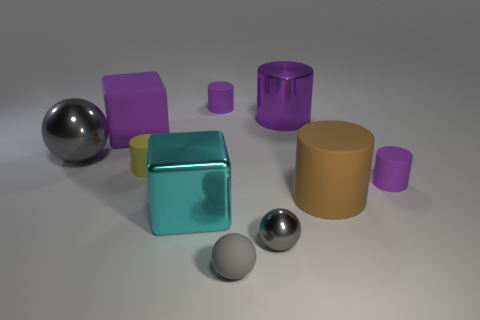How many gray balls must be subtracted to get 1 gray balls? 2 Subtract all purple metal cylinders. How many cylinders are left? 4 Subtract 3 cylinders. How many cylinders are left? 2 Subtract all blue blocks. How many purple cylinders are left? 3 Subtract all yellow cylinders. How many cylinders are left? 4 Subtract all yellow cylinders. Subtract all cyan balls. How many cylinders are left? 4 Subtract all cubes. How many objects are left? 8 Subtract 1 purple cylinders. How many objects are left? 9 Subtract all small gray metallic objects. Subtract all rubber things. How many objects are left? 3 Add 3 small gray shiny things. How many small gray shiny things are left? 4 